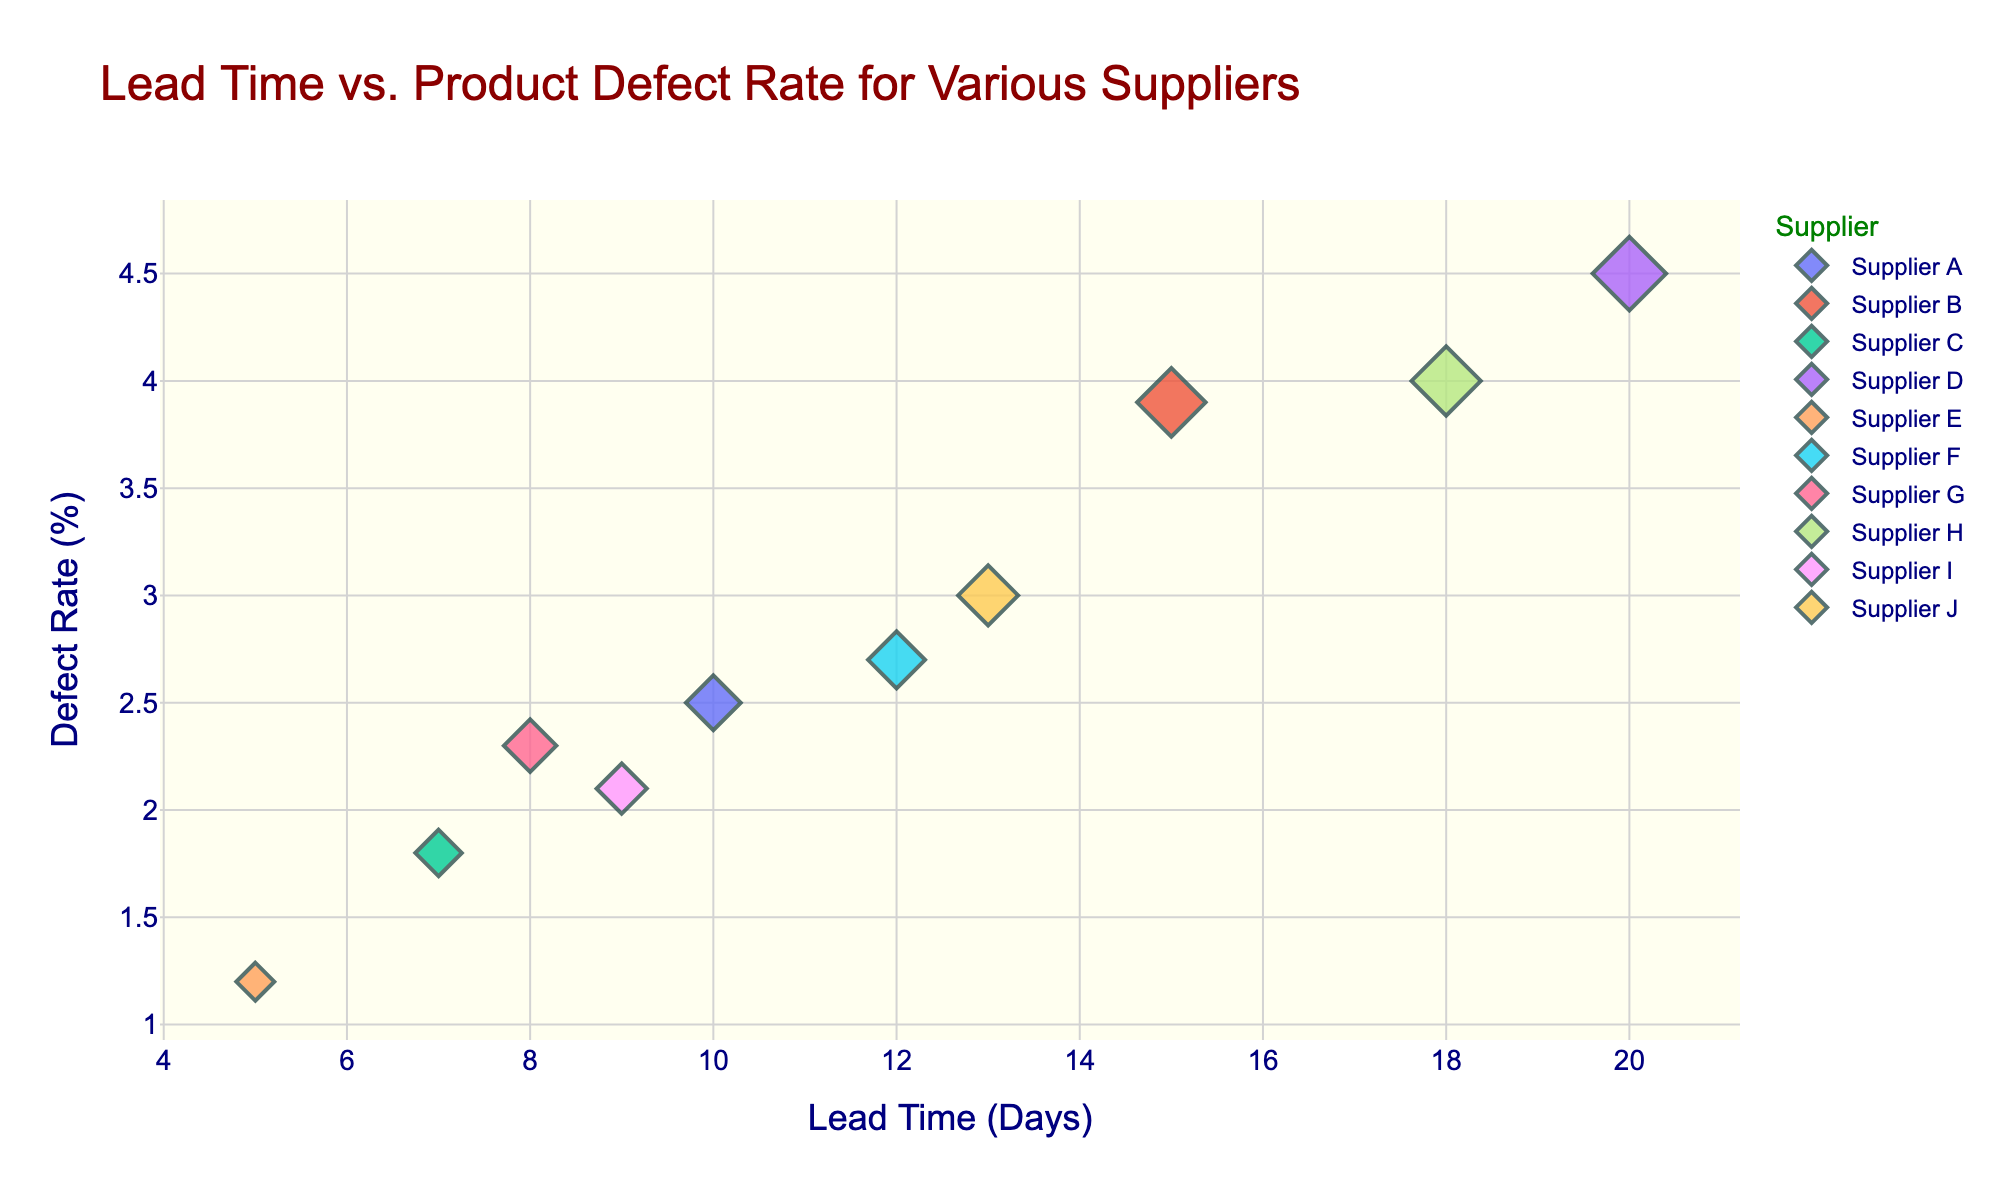What is the title of the scatter plot? The title of the figure is located at the top and is written in a large font size. By looking at the top of the figure, we can read the title.
Answer: Lead Time vs. Product Defect Rate for Various Suppliers How many suppliers are represented in the scatter plot? Each data point represents a different supplier, and the legend shows a unique color for each supplier. Counting the distinct colors or checking the data labels associated with each point gives us the number of suppliers.
Answer: 10 Which supplier has the highest product defect rate? Look at the data points on the y-axis to find the one with the highest value. The data point located at the top of the plot represents the highest product defect rate.
Answer: Supplier D Which supplier has the shortest lead time? Check the x-axis to find the data point with the lowest numerical value, indicating the shortest lead time. The data point furthest to the left corresponds to the shortest lead time.
Answer: Supplier E What is the average product defect rate of Supplier B and Supplier D? First, locate Supplier B and Supplier D on the scatter plot. Supplier B has a defect rate of 3.9% and Supplier D has a defect rate of 4.5%. The average of 3.9% and 4.5% is calculated as (3.9 + 4.5) / 2.
Answer: 4.2% Which supplier has both a low lead time and a low product defect rate? Identify the data points that are situated towards the bottom and left sections of the scatter plot, indicating low values for both axes.
Answer: Supplier E Is there a supplier with a lead time longer than 15 days but a product defect rate lower than 4%? Look for data points to the right of the 15 days mark on the x-axis and below the 4% mark on the y-axis.
Answer: No How does Supplier F compare to Supplier J in terms of lead time and product defect rate? Identify the data points for Supplier F and Supplier J. Supplier F has a lead time of 12 days and a defect rate of 2.7%. Supplier J has a lead time of 13 days and a defect rate of 3.0%. By comparing these values:
Lead Time: Supplier F < Supplier J
Defect Rate: Supplier F < Supplier J
Answer: Supplier F has a shorter lead time and a lower defect rate than Supplier J Which supplier is closest to the origin (0,0) in the plot? Identify the data point with the smallest lead time and smallest defect rate. The origin (0,0) represents the theoretical point with the lowest values in both axes.
Answer: Supplier E What trend, if any, can be observed between lead time and product defect rate? By examining the scatter plot, observe the positioning of data points. Most points with higher lead times tend to have higher defect rates, and those with lower lead times tend to have lower defect rates. This suggests a positive correlation between lead time and defect rate.
Answer: Positive correlation 